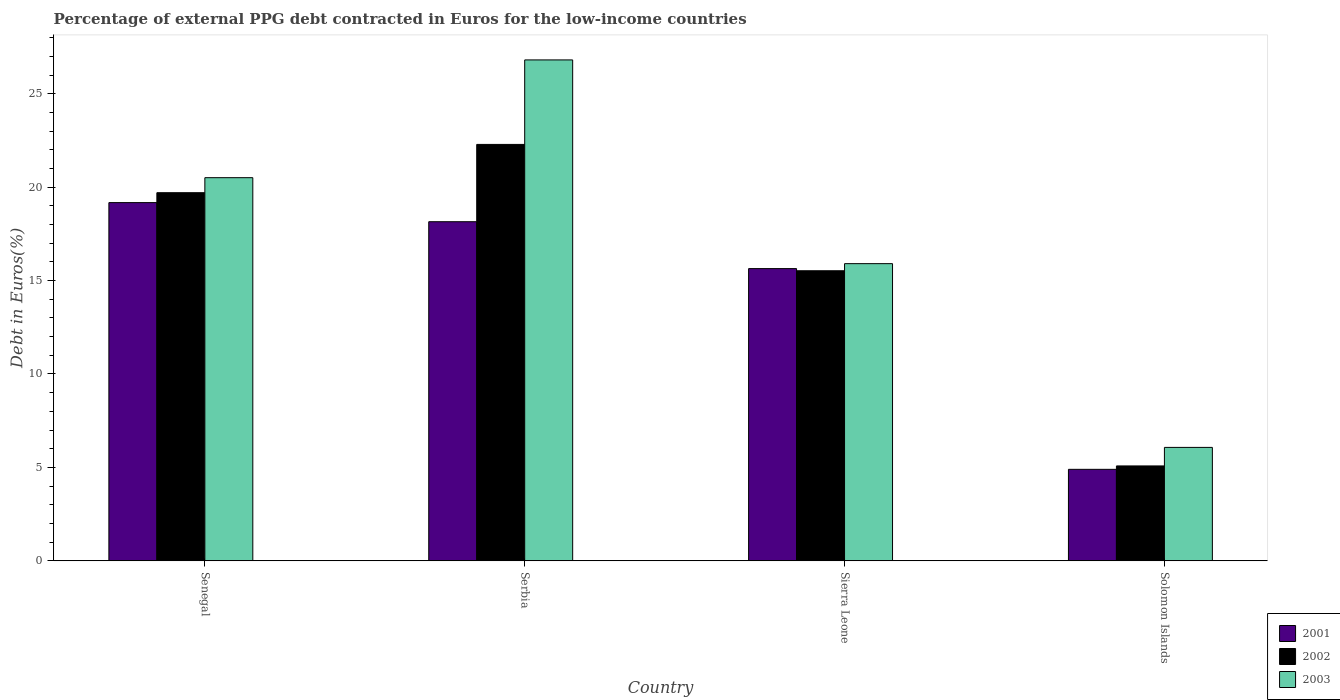How many different coloured bars are there?
Offer a very short reply. 3. How many groups of bars are there?
Provide a short and direct response. 4. Are the number of bars on each tick of the X-axis equal?
Keep it short and to the point. Yes. How many bars are there on the 2nd tick from the right?
Your answer should be compact. 3. What is the label of the 2nd group of bars from the left?
Keep it short and to the point. Serbia. What is the percentage of external PPG debt contracted in Euros in 2002 in Solomon Islands?
Provide a succinct answer. 5.08. Across all countries, what is the maximum percentage of external PPG debt contracted in Euros in 2002?
Your response must be concise. 22.29. Across all countries, what is the minimum percentage of external PPG debt contracted in Euros in 2003?
Provide a succinct answer. 6.07. In which country was the percentage of external PPG debt contracted in Euros in 2001 maximum?
Ensure brevity in your answer.  Senegal. In which country was the percentage of external PPG debt contracted in Euros in 2001 minimum?
Your answer should be very brief. Solomon Islands. What is the total percentage of external PPG debt contracted in Euros in 2001 in the graph?
Provide a succinct answer. 57.86. What is the difference between the percentage of external PPG debt contracted in Euros in 2002 in Serbia and that in Sierra Leone?
Offer a terse response. 6.76. What is the difference between the percentage of external PPG debt contracted in Euros in 2003 in Solomon Islands and the percentage of external PPG debt contracted in Euros in 2002 in Serbia?
Ensure brevity in your answer.  -16.22. What is the average percentage of external PPG debt contracted in Euros in 2002 per country?
Offer a terse response. 15.65. What is the difference between the percentage of external PPG debt contracted in Euros of/in 2003 and percentage of external PPG debt contracted in Euros of/in 2002 in Solomon Islands?
Make the answer very short. 0.99. In how many countries, is the percentage of external PPG debt contracted in Euros in 2003 greater than 1 %?
Offer a very short reply. 4. What is the ratio of the percentage of external PPG debt contracted in Euros in 2002 in Serbia to that in Solomon Islands?
Offer a terse response. 4.39. Is the difference between the percentage of external PPG debt contracted in Euros in 2003 in Serbia and Sierra Leone greater than the difference between the percentage of external PPG debt contracted in Euros in 2002 in Serbia and Sierra Leone?
Provide a short and direct response. Yes. What is the difference between the highest and the second highest percentage of external PPG debt contracted in Euros in 2001?
Your response must be concise. -1.02. What is the difference between the highest and the lowest percentage of external PPG debt contracted in Euros in 2002?
Provide a short and direct response. 17.21. What does the 1st bar from the left in Solomon Islands represents?
Ensure brevity in your answer.  2001. What does the 1st bar from the right in Sierra Leone represents?
Provide a short and direct response. 2003. Is it the case that in every country, the sum of the percentage of external PPG debt contracted in Euros in 2003 and percentage of external PPG debt contracted in Euros in 2001 is greater than the percentage of external PPG debt contracted in Euros in 2002?
Offer a very short reply. Yes. How many bars are there?
Provide a short and direct response. 12. How many countries are there in the graph?
Provide a short and direct response. 4. Where does the legend appear in the graph?
Ensure brevity in your answer.  Bottom right. How many legend labels are there?
Make the answer very short. 3. What is the title of the graph?
Keep it short and to the point. Percentage of external PPG debt contracted in Euros for the low-income countries. What is the label or title of the X-axis?
Offer a very short reply. Country. What is the label or title of the Y-axis?
Keep it short and to the point. Debt in Euros(%). What is the Debt in Euros(%) in 2001 in Senegal?
Offer a terse response. 19.17. What is the Debt in Euros(%) of 2002 in Senegal?
Provide a short and direct response. 19.7. What is the Debt in Euros(%) of 2003 in Senegal?
Offer a terse response. 20.51. What is the Debt in Euros(%) in 2001 in Serbia?
Give a very brief answer. 18.15. What is the Debt in Euros(%) of 2002 in Serbia?
Your answer should be very brief. 22.29. What is the Debt in Euros(%) of 2003 in Serbia?
Ensure brevity in your answer.  26.81. What is the Debt in Euros(%) in 2001 in Sierra Leone?
Offer a very short reply. 15.64. What is the Debt in Euros(%) in 2002 in Sierra Leone?
Your answer should be very brief. 15.53. What is the Debt in Euros(%) of 2003 in Sierra Leone?
Your answer should be compact. 15.91. What is the Debt in Euros(%) of 2001 in Solomon Islands?
Your response must be concise. 4.9. What is the Debt in Euros(%) of 2002 in Solomon Islands?
Offer a very short reply. 5.08. What is the Debt in Euros(%) of 2003 in Solomon Islands?
Make the answer very short. 6.07. Across all countries, what is the maximum Debt in Euros(%) of 2001?
Give a very brief answer. 19.17. Across all countries, what is the maximum Debt in Euros(%) in 2002?
Provide a succinct answer. 22.29. Across all countries, what is the maximum Debt in Euros(%) of 2003?
Offer a very short reply. 26.81. Across all countries, what is the minimum Debt in Euros(%) of 2001?
Provide a succinct answer. 4.9. Across all countries, what is the minimum Debt in Euros(%) of 2002?
Give a very brief answer. 5.08. Across all countries, what is the minimum Debt in Euros(%) of 2003?
Your response must be concise. 6.07. What is the total Debt in Euros(%) of 2001 in the graph?
Your response must be concise. 57.86. What is the total Debt in Euros(%) of 2002 in the graph?
Your answer should be very brief. 62.59. What is the total Debt in Euros(%) of 2003 in the graph?
Offer a very short reply. 69.29. What is the difference between the Debt in Euros(%) of 2001 in Senegal and that in Serbia?
Give a very brief answer. 1.02. What is the difference between the Debt in Euros(%) in 2002 in Senegal and that in Serbia?
Provide a short and direct response. -2.58. What is the difference between the Debt in Euros(%) of 2003 in Senegal and that in Serbia?
Offer a very short reply. -6.3. What is the difference between the Debt in Euros(%) in 2001 in Senegal and that in Sierra Leone?
Ensure brevity in your answer.  3.53. What is the difference between the Debt in Euros(%) in 2002 in Senegal and that in Sierra Leone?
Give a very brief answer. 4.18. What is the difference between the Debt in Euros(%) in 2003 in Senegal and that in Sierra Leone?
Your response must be concise. 4.6. What is the difference between the Debt in Euros(%) in 2001 in Senegal and that in Solomon Islands?
Give a very brief answer. 14.28. What is the difference between the Debt in Euros(%) in 2002 in Senegal and that in Solomon Islands?
Ensure brevity in your answer.  14.62. What is the difference between the Debt in Euros(%) of 2003 in Senegal and that in Solomon Islands?
Provide a short and direct response. 14.44. What is the difference between the Debt in Euros(%) of 2001 in Serbia and that in Sierra Leone?
Keep it short and to the point. 2.51. What is the difference between the Debt in Euros(%) of 2002 in Serbia and that in Sierra Leone?
Your answer should be compact. 6.76. What is the difference between the Debt in Euros(%) of 2003 in Serbia and that in Sierra Leone?
Make the answer very short. 10.9. What is the difference between the Debt in Euros(%) of 2001 in Serbia and that in Solomon Islands?
Keep it short and to the point. 13.25. What is the difference between the Debt in Euros(%) of 2002 in Serbia and that in Solomon Islands?
Give a very brief answer. 17.21. What is the difference between the Debt in Euros(%) of 2003 in Serbia and that in Solomon Islands?
Your response must be concise. 20.74. What is the difference between the Debt in Euros(%) of 2001 in Sierra Leone and that in Solomon Islands?
Offer a terse response. 10.74. What is the difference between the Debt in Euros(%) of 2002 in Sierra Leone and that in Solomon Islands?
Ensure brevity in your answer.  10.45. What is the difference between the Debt in Euros(%) of 2003 in Sierra Leone and that in Solomon Islands?
Keep it short and to the point. 9.83. What is the difference between the Debt in Euros(%) in 2001 in Senegal and the Debt in Euros(%) in 2002 in Serbia?
Your response must be concise. -3.11. What is the difference between the Debt in Euros(%) of 2001 in Senegal and the Debt in Euros(%) of 2003 in Serbia?
Offer a very short reply. -7.64. What is the difference between the Debt in Euros(%) in 2002 in Senegal and the Debt in Euros(%) in 2003 in Serbia?
Ensure brevity in your answer.  -7.11. What is the difference between the Debt in Euros(%) of 2001 in Senegal and the Debt in Euros(%) of 2002 in Sierra Leone?
Your answer should be compact. 3.65. What is the difference between the Debt in Euros(%) in 2001 in Senegal and the Debt in Euros(%) in 2003 in Sierra Leone?
Offer a terse response. 3.27. What is the difference between the Debt in Euros(%) of 2002 in Senegal and the Debt in Euros(%) of 2003 in Sierra Leone?
Offer a terse response. 3.8. What is the difference between the Debt in Euros(%) of 2001 in Senegal and the Debt in Euros(%) of 2002 in Solomon Islands?
Make the answer very short. 14.09. What is the difference between the Debt in Euros(%) in 2001 in Senegal and the Debt in Euros(%) in 2003 in Solomon Islands?
Provide a succinct answer. 13.1. What is the difference between the Debt in Euros(%) in 2002 in Senegal and the Debt in Euros(%) in 2003 in Solomon Islands?
Give a very brief answer. 13.63. What is the difference between the Debt in Euros(%) in 2001 in Serbia and the Debt in Euros(%) in 2002 in Sierra Leone?
Your answer should be very brief. 2.62. What is the difference between the Debt in Euros(%) of 2001 in Serbia and the Debt in Euros(%) of 2003 in Sierra Leone?
Your answer should be compact. 2.24. What is the difference between the Debt in Euros(%) in 2002 in Serbia and the Debt in Euros(%) in 2003 in Sierra Leone?
Provide a succinct answer. 6.38. What is the difference between the Debt in Euros(%) in 2001 in Serbia and the Debt in Euros(%) in 2002 in Solomon Islands?
Give a very brief answer. 13.07. What is the difference between the Debt in Euros(%) in 2001 in Serbia and the Debt in Euros(%) in 2003 in Solomon Islands?
Provide a short and direct response. 12.08. What is the difference between the Debt in Euros(%) in 2002 in Serbia and the Debt in Euros(%) in 2003 in Solomon Islands?
Your answer should be very brief. 16.22. What is the difference between the Debt in Euros(%) in 2001 in Sierra Leone and the Debt in Euros(%) in 2002 in Solomon Islands?
Give a very brief answer. 10.56. What is the difference between the Debt in Euros(%) of 2001 in Sierra Leone and the Debt in Euros(%) of 2003 in Solomon Islands?
Offer a very short reply. 9.57. What is the difference between the Debt in Euros(%) of 2002 in Sierra Leone and the Debt in Euros(%) of 2003 in Solomon Islands?
Your answer should be very brief. 9.45. What is the average Debt in Euros(%) in 2001 per country?
Your answer should be compact. 14.46. What is the average Debt in Euros(%) of 2002 per country?
Offer a very short reply. 15.65. What is the average Debt in Euros(%) of 2003 per country?
Provide a short and direct response. 17.32. What is the difference between the Debt in Euros(%) in 2001 and Debt in Euros(%) in 2002 in Senegal?
Ensure brevity in your answer.  -0.53. What is the difference between the Debt in Euros(%) of 2001 and Debt in Euros(%) of 2003 in Senegal?
Provide a succinct answer. -1.33. What is the difference between the Debt in Euros(%) of 2002 and Debt in Euros(%) of 2003 in Senegal?
Your answer should be very brief. -0.8. What is the difference between the Debt in Euros(%) in 2001 and Debt in Euros(%) in 2002 in Serbia?
Your answer should be very brief. -4.14. What is the difference between the Debt in Euros(%) in 2001 and Debt in Euros(%) in 2003 in Serbia?
Make the answer very short. -8.66. What is the difference between the Debt in Euros(%) in 2002 and Debt in Euros(%) in 2003 in Serbia?
Ensure brevity in your answer.  -4.52. What is the difference between the Debt in Euros(%) of 2001 and Debt in Euros(%) of 2002 in Sierra Leone?
Offer a very short reply. 0.12. What is the difference between the Debt in Euros(%) in 2001 and Debt in Euros(%) in 2003 in Sierra Leone?
Your answer should be very brief. -0.26. What is the difference between the Debt in Euros(%) in 2002 and Debt in Euros(%) in 2003 in Sierra Leone?
Make the answer very short. -0.38. What is the difference between the Debt in Euros(%) of 2001 and Debt in Euros(%) of 2002 in Solomon Islands?
Keep it short and to the point. -0.18. What is the difference between the Debt in Euros(%) of 2001 and Debt in Euros(%) of 2003 in Solomon Islands?
Make the answer very short. -1.17. What is the difference between the Debt in Euros(%) in 2002 and Debt in Euros(%) in 2003 in Solomon Islands?
Your answer should be compact. -0.99. What is the ratio of the Debt in Euros(%) in 2001 in Senegal to that in Serbia?
Offer a very short reply. 1.06. What is the ratio of the Debt in Euros(%) of 2002 in Senegal to that in Serbia?
Keep it short and to the point. 0.88. What is the ratio of the Debt in Euros(%) in 2003 in Senegal to that in Serbia?
Provide a succinct answer. 0.76. What is the ratio of the Debt in Euros(%) of 2001 in Senegal to that in Sierra Leone?
Offer a very short reply. 1.23. What is the ratio of the Debt in Euros(%) in 2002 in Senegal to that in Sierra Leone?
Keep it short and to the point. 1.27. What is the ratio of the Debt in Euros(%) of 2003 in Senegal to that in Sierra Leone?
Give a very brief answer. 1.29. What is the ratio of the Debt in Euros(%) of 2001 in Senegal to that in Solomon Islands?
Your answer should be compact. 3.92. What is the ratio of the Debt in Euros(%) of 2002 in Senegal to that in Solomon Islands?
Give a very brief answer. 3.88. What is the ratio of the Debt in Euros(%) of 2003 in Senegal to that in Solomon Islands?
Your answer should be very brief. 3.38. What is the ratio of the Debt in Euros(%) of 2001 in Serbia to that in Sierra Leone?
Your answer should be very brief. 1.16. What is the ratio of the Debt in Euros(%) of 2002 in Serbia to that in Sierra Leone?
Offer a very short reply. 1.44. What is the ratio of the Debt in Euros(%) in 2003 in Serbia to that in Sierra Leone?
Ensure brevity in your answer.  1.69. What is the ratio of the Debt in Euros(%) of 2001 in Serbia to that in Solomon Islands?
Make the answer very short. 3.71. What is the ratio of the Debt in Euros(%) of 2002 in Serbia to that in Solomon Islands?
Your response must be concise. 4.39. What is the ratio of the Debt in Euros(%) in 2003 in Serbia to that in Solomon Islands?
Provide a short and direct response. 4.42. What is the ratio of the Debt in Euros(%) of 2001 in Sierra Leone to that in Solomon Islands?
Give a very brief answer. 3.19. What is the ratio of the Debt in Euros(%) of 2002 in Sierra Leone to that in Solomon Islands?
Ensure brevity in your answer.  3.06. What is the ratio of the Debt in Euros(%) in 2003 in Sierra Leone to that in Solomon Islands?
Your answer should be very brief. 2.62. What is the difference between the highest and the second highest Debt in Euros(%) of 2001?
Make the answer very short. 1.02. What is the difference between the highest and the second highest Debt in Euros(%) of 2002?
Your response must be concise. 2.58. What is the difference between the highest and the second highest Debt in Euros(%) in 2003?
Offer a very short reply. 6.3. What is the difference between the highest and the lowest Debt in Euros(%) in 2001?
Your response must be concise. 14.28. What is the difference between the highest and the lowest Debt in Euros(%) of 2002?
Offer a very short reply. 17.21. What is the difference between the highest and the lowest Debt in Euros(%) in 2003?
Your response must be concise. 20.74. 